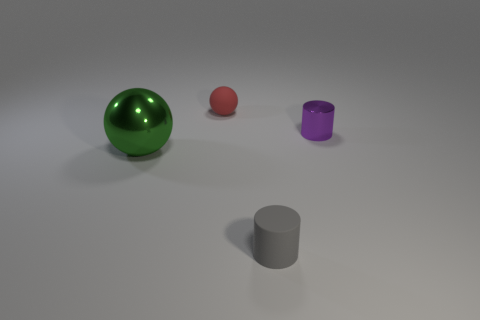Add 3 red rubber balls. How many objects exist? 7 Subtract all cylinders. Subtract all gray things. How many objects are left? 1 Add 3 big metal spheres. How many big metal spheres are left? 4 Add 4 tiny rubber cylinders. How many tiny rubber cylinders exist? 5 Subtract 0 gray cubes. How many objects are left? 4 